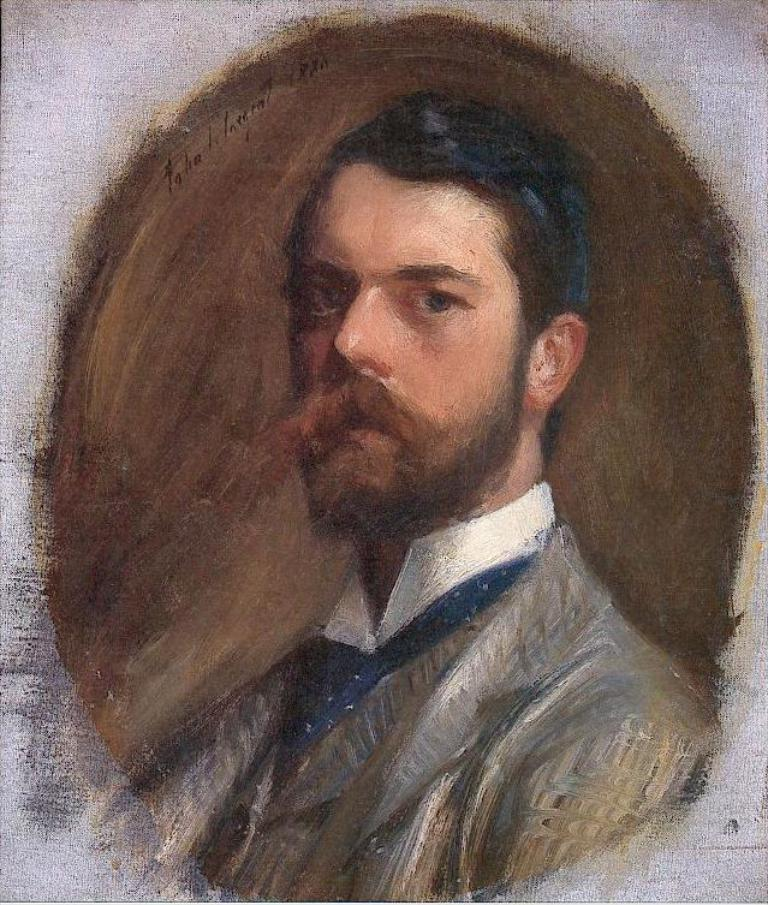What is the main subject of the image? There is an art piece in the image. Can you describe the art piece? The art piece contains a person. What type of sheet is being used by the person in the art piece? There is no sheet present in the image; it only contains a person in an art piece. 